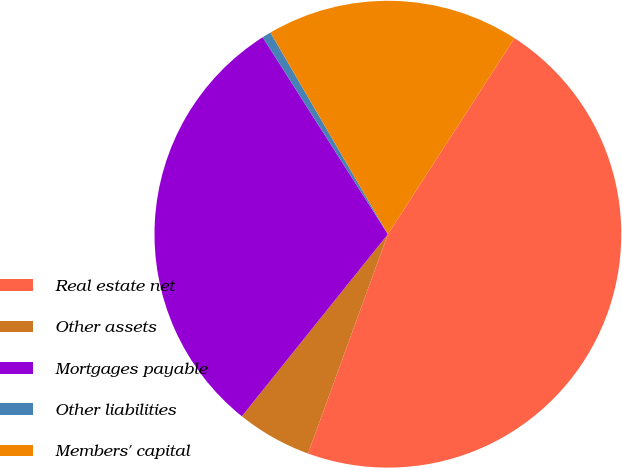<chart> <loc_0><loc_0><loc_500><loc_500><pie_chart><fcel>Real estate net<fcel>Other assets<fcel>Mortgages payable<fcel>Other liabilities<fcel>Members' capital<nl><fcel>46.44%<fcel>5.2%<fcel>30.23%<fcel>0.62%<fcel>17.52%<nl></chart> 